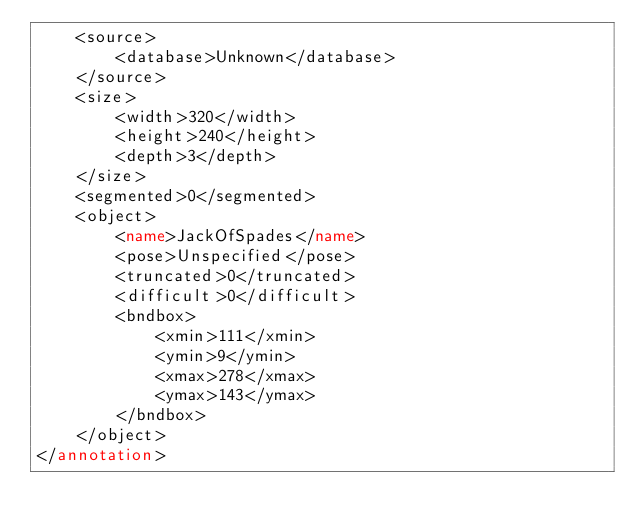Convert code to text. <code><loc_0><loc_0><loc_500><loc_500><_XML_>	<source>
		<database>Unknown</database>
	</source>
	<size>
		<width>320</width>
		<height>240</height>
		<depth>3</depth>
	</size>
	<segmented>0</segmented>
	<object>
		<name>JackOfSpades</name>
		<pose>Unspecified</pose>
		<truncated>0</truncated>
		<difficult>0</difficult>
		<bndbox>
			<xmin>111</xmin>
			<ymin>9</ymin>
			<xmax>278</xmax>
			<ymax>143</ymax>
		</bndbox>
	</object>
</annotation>
</code> 